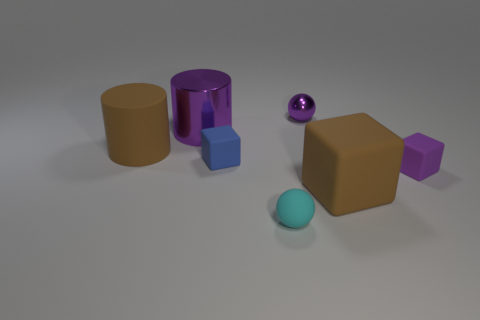What shape is the big matte thing that is the same color as the large matte cylinder?
Your answer should be very brief. Cube. Does the metallic thing that is right of the metallic cylinder have the same color as the large block?
Provide a short and direct response. No. There is a big rubber object on the left side of the metallic object left of the small blue rubber thing; what shape is it?
Offer a terse response. Cylinder. How many things are either tiny things behind the small cyan matte sphere or small matte objects in front of the tiny blue matte object?
Keep it short and to the point. 4. The purple thing that is made of the same material as the large purple cylinder is what shape?
Provide a succinct answer. Sphere. Is there any other thing of the same color as the big shiny cylinder?
Provide a succinct answer. Yes. There is a purple object that is the same shape as the small cyan thing; what material is it?
Make the answer very short. Metal. What number of other things are there of the same size as the cyan object?
Offer a terse response. 3. What material is the brown block?
Give a very brief answer. Rubber. Is the number of brown matte things that are left of the big purple shiny thing greater than the number of objects?
Your answer should be compact. No. 